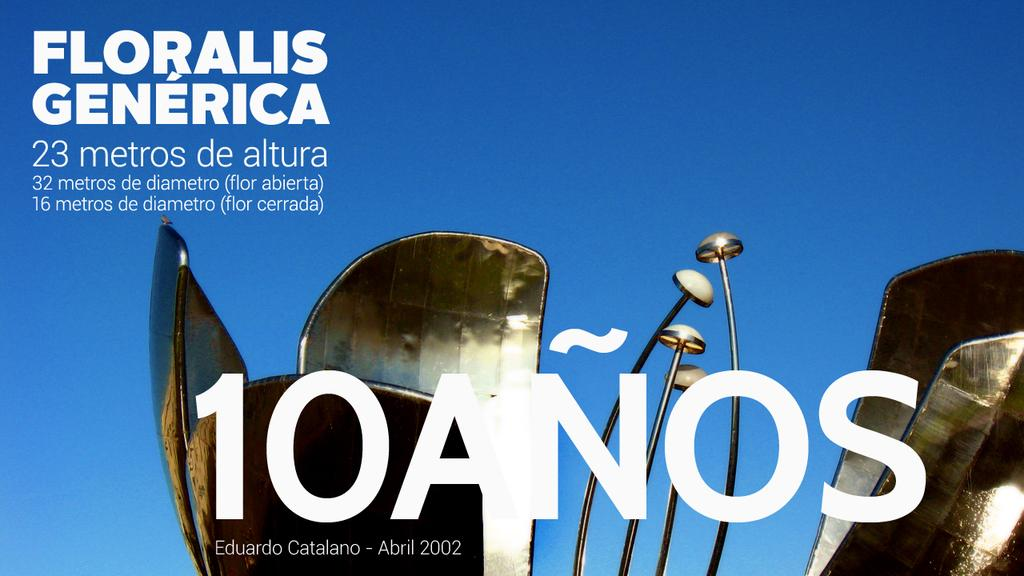Provide a one-sentence caption for the provided image. An ad celebrating 10 Anos features a bright blue sky and features the words "Floralis Generica.". 